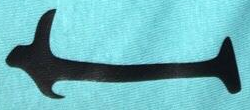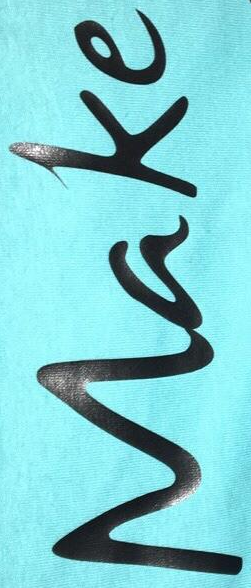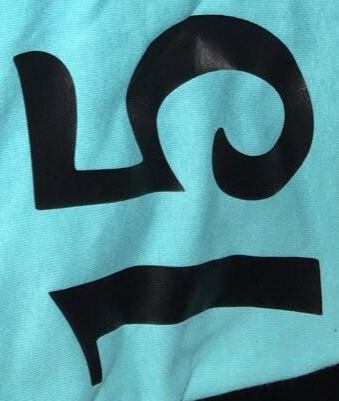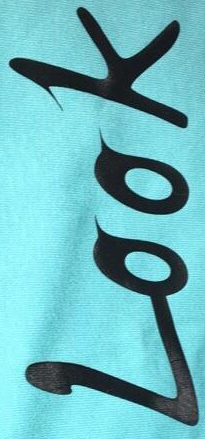What words can you see in these images in sequence, separated by a semicolon? I; Make; 15; Look 